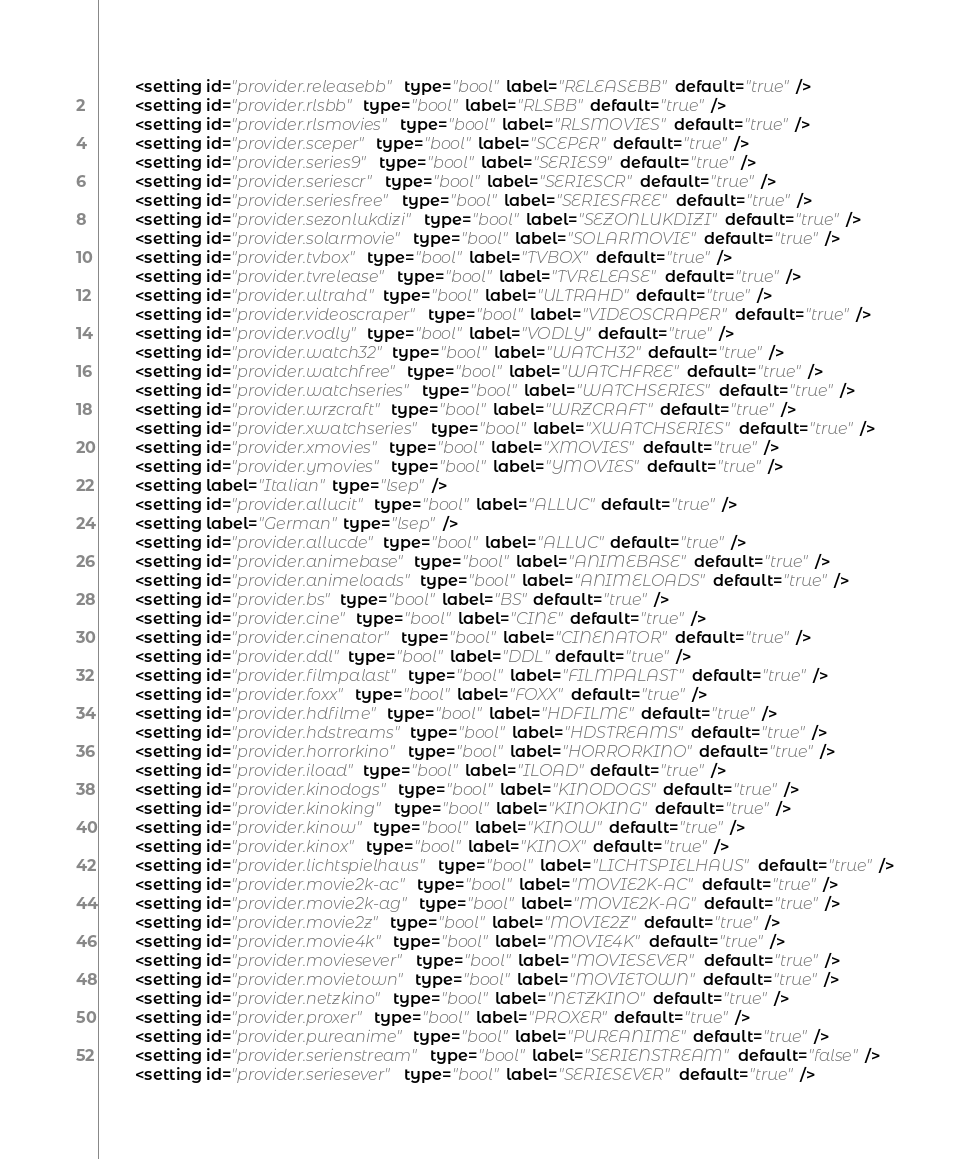<code> <loc_0><loc_0><loc_500><loc_500><_XML_>        <setting id="provider.releasebb" type="bool" label="RELEASEBB" default="true" />
        <setting id="provider.rlsbb" type="bool" label="RLSBB" default="true" />
        <setting id="provider.rlsmovies" type="bool" label="RLSMOVIES" default="true" />
        <setting id="provider.sceper" type="bool" label="SCEPER" default="true" />
        <setting id="provider.series9" type="bool" label="SERIES9" default="true" />
        <setting id="provider.seriescr" type="bool" label="SERIESCR" default="true" />
        <setting id="provider.seriesfree" type="bool" label="SERIESFREE" default="true" />
        <setting id="provider.sezonlukdizi" type="bool" label="SEZONLUKDIZI" default="true" />
        <setting id="provider.solarmovie" type="bool" label="SOLARMOVIE" default="true" />
        <setting id="provider.tvbox" type="bool" label="TVBOX" default="true" />
        <setting id="provider.tvrelease" type="bool" label="TVRELEASE" default="true" />
        <setting id="provider.ultrahd" type="bool" label="ULTRAHD" default="true" />
        <setting id="provider.videoscraper" type="bool" label="VIDEOSCRAPER" default="true" />
        <setting id="provider.vodly" type="bool" label="VODLY" default="true" />
        <setting id="provider.watch32" type="bool" label="WATCH32" default="true" />
        <setting id="provider.watchfree" type="bool" label="WATCHFREE" default="true" />
        <setting id="provider.watchseries" type="bool" label="WATCHSERIES" default="true" />
        <setting id="provider.wrzcraft" type="bool" label="WRZCRAFT" default="true" />
        <setting id="provider.xwatchseries" type="bool" label="XWATCHSERIES" default="true" />
        <setting id="provider.xmovies" type="bool" label="XMOVIES" default="true" />
        <setting id="provider.ymovies" type="bool" label="YMOVIES" default="true" />
        <setting label="Italian" type="lsep" />
        <setting id="provider.allucit" type="bool" label="ALLUC" default="true" />
        <setting label="German" type="lsep" />
        <setting id="provider.allucde" type="bool" label="ALLUC" default="true" />
        <setting id="provider.animebase" type="bool" label="ANIMEBASE" default="true" />
        <setting id="provider.animeloads" type="bool" label="ANIMELOADS" default="true" />
        <setting id="provider.bs" type="bool" label="BS" default="true" />
        <setting id="provider.cine" type="bool" label="CINE" default="true" />
        <setting id="provider.cinenator" type="bool" label="CINENATOR" default="true" />
        <setting id="provider.ddl" type="bool" label="DDL" default="true" />
        <setting id="provider.filmpalast" type="bool" label="FILMPALAST" default="true" />
        <setting id="provider.foxx" type="bool" label="FOXX" default="true" />
        <setting id="provider.hdfilme" type="bool" label="HDFILME" default="true" />
        <setting id="provider.hdstreams" type="bool" label="HDSTREAMS" default="true" />
        <setting id="provider.horrorkino" type="bool" label="HORRORKINO" default="true" />
        <setting id="provider.iload" type="bool" label="ILOAD" default="true" />
        <setting id="provider.kinodogs" type="bool" label="KINODOGS" default="true" />
        <setting id="provider.kinoking" type="bool" label="KINOKING" default="true" />
        <setting id="provider.kinow" type="bool" label="KINOW" default="true" />
        <setting id="provider.kinox" type="bool" label="KINOX" default="true" />
        <setting id="provider.lichtspielhaus" type="bool" label="LICHTSPIELHAUS" default="true" />
        <setting id="provider.movie2k-ac" type="bool" label="MOVIE2K-AC" default="true" />
        <setting id="provider.movie2k-ag" type="bool" label="MOVIE2K-AG" default="true" />
        <setting id="provider.movie2z" type="bool" label="MOVIE2Z" default="true" />
        <setting id="provider.movie4k" type="bool" label="MOVIE4K" default="true" />
        <setting id="provider.moviesever" type="bool" label="MOVIESEVER" default="true" />
        <setting id="provider.movietown" type="bool" label="MOVIETOWN" default="true" />
        <setting id="provider.netzkino" type="bool" label="NETZKINO" default="true" />
        <setting id="provider.proxer" type="bool" label="PROXER" default="true" />
        <setting id="provider.pureanime" type="bool" label="PUREANIME" default="true" />
        <setting id="provider.serienstream" type="bool" label="SERIENSTREAM" default="false" />
        <setting id="provider.seriesever" type="bool" label="SERIESEVER" default="true" /></code> 